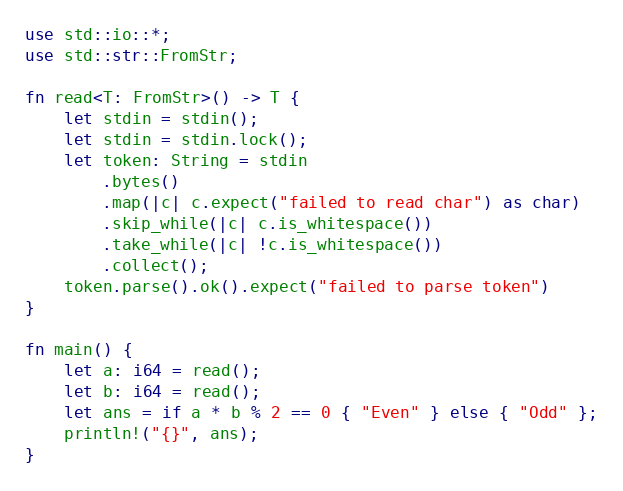Convert code to text. <code><loc_0><loc_0><loc_500><loc_500><_Rust_>use std::io::*;
use std::str::FromStr;

fn read<T: FromStr>() -> T {
    let stdin = stdin();
    let stdin = stdin.lock();
    let token: String = stdin
        .bytes()
        .map(|c| c.expect("failed to read char") as char)
        .skip_while(|c| c.is_whitespace())
        .take_while(|c| !c.is_whitespace())
        .collect();
    token.parse().ok().expect("failed to parse token")
}

fn main() {
    let a: i64 = read();
    let b: i64 = read();
    let ans = if a * b % 2 == 0 { "Even" } else { "Odd" };
    println!("{}", ans);
}
</code> 